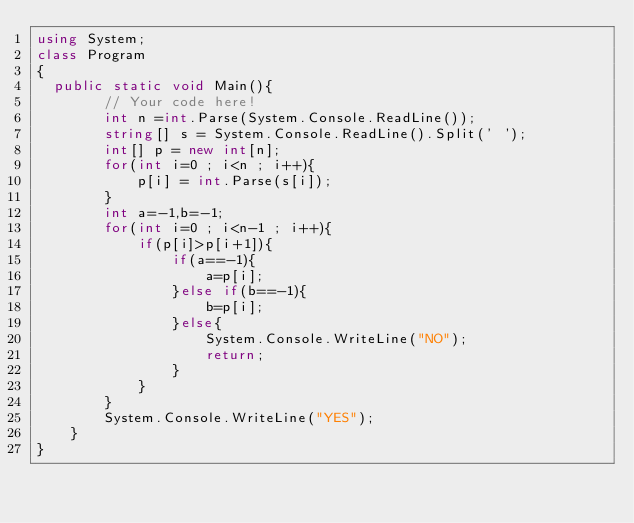Convert code to text. <code><loc_0><loc_0><loc_500><loc_500><_C#_>using System;
class Program
{
  public static void Main(){
        // Your code here!
        int n =int.Parse(System.Console.ReadLine());
        string[] s = System.Console.ReadLine().Split(' ');
        int[] p = new int[n];
        for(int i=0 ; i<n ; i++){
            p[i] = int.Parse(s[i]);
        }
        int a=-1,b=-1;
        for(int i=0 ; i<n-1 ; i++){
            if(p[i]>p[i+1]){
                if(a==-1){
                    a=p[i];
                }else if(b==-1){
                    b=p[i];
                }else{
                    System.Console.WriteLine("NO");
                    return;
                }
            }
        }
        System.Console.WriteLine("YES");
    }
}</code> 